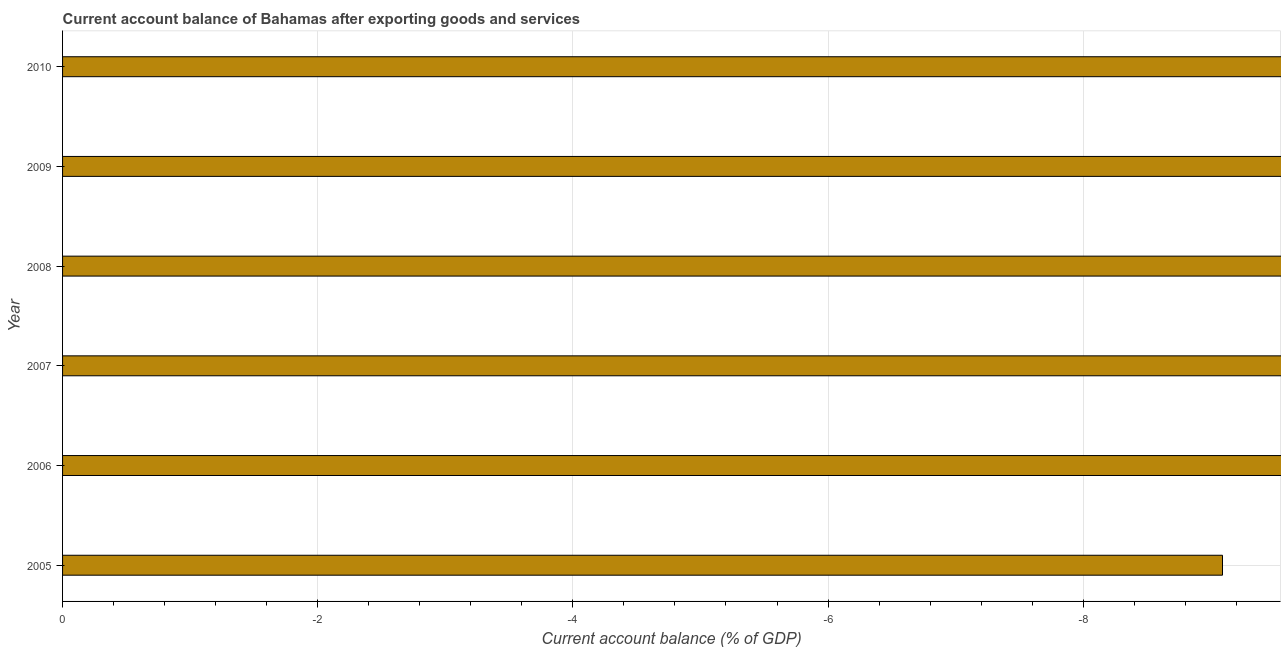Does the graph contain grids?
Provide a succinct answer. Yes. What is the title of the graph?
Offer a terse response. Current account balance of Bahamas after exporting goods and services. What is the label or title of the X-axis?
Offer a terse response. Current account balance (% of GDP). What is the current account balance in 2009?
Keep it short and to the point. 0. What is the average current account balance per year?
Your answer should be compact. 0. What is the median current account balance?
Offer a terse response. 0. In how many years, is the current account balance greater than -4 %?
Provide a succinct answer. 0. In how many years, is the current account balance greater than the average current account balance taken over all years?
Your answer should be compact. 0. What is the difference between two consecutive major ticks on the X-axis?
Make the answer very short. 2. What is the Current account balance (% of GDP) in 2006?
Keep it short and to the point. 0. What is the Current account balance (% of GDP) of 2007?
Keep it short and to the point. 0. What is the Current account balance (% of GDP) of 2009?
Offer a terse response. 0. 